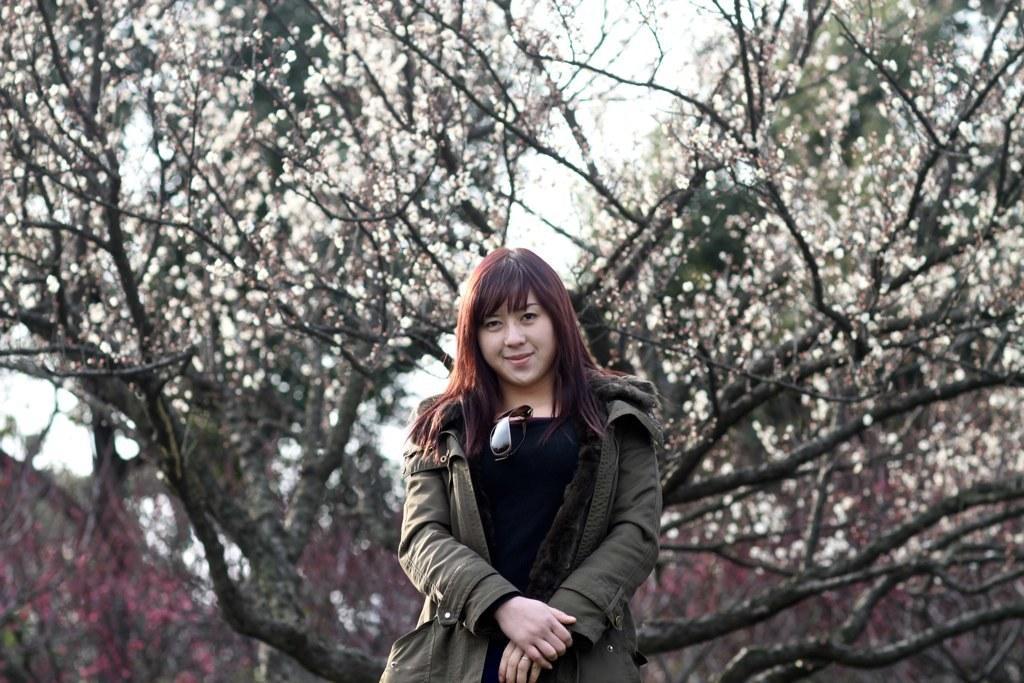Please provide a concise description of this image. In this image there is a woman standing. She is wearing a jacket. Background there are trees. Behind there is sky. 